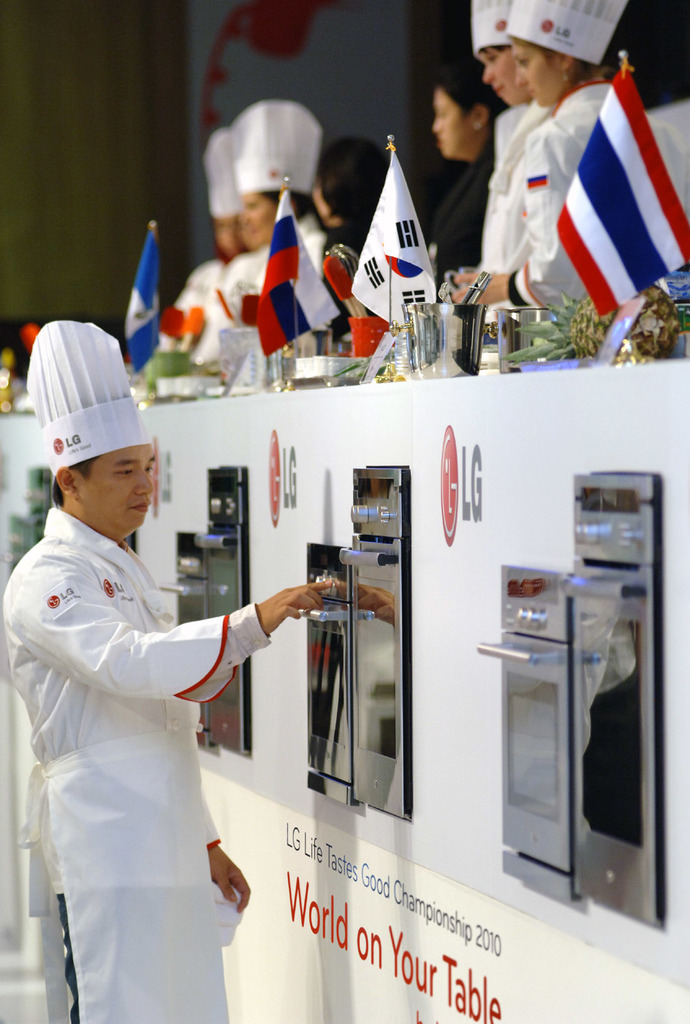Provide a one-sentence caption for the provided image. Chefs from different countries compete at the LG Life Tastes Good Championship in 2010, showcasing their culinary skills in a high-stakes cooking contest. 